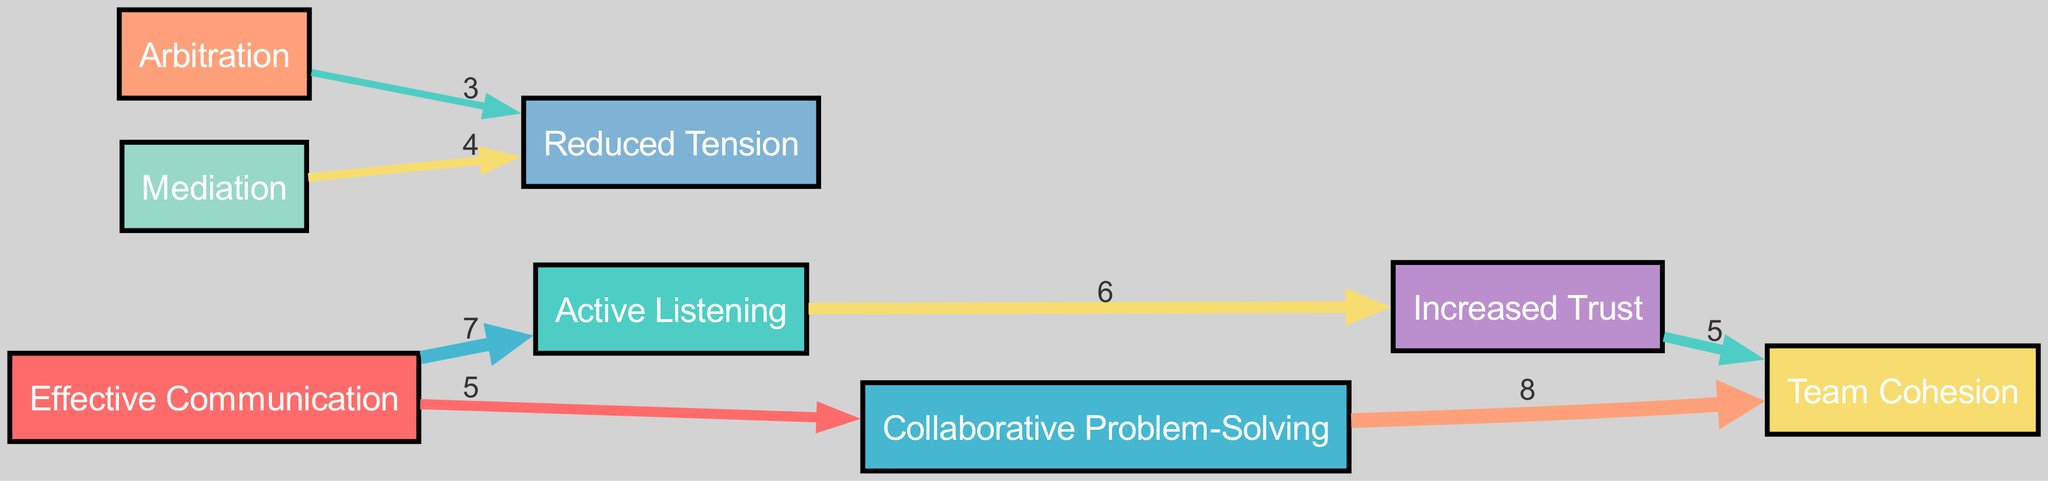What is the node that connects "Effective Communication" to "Active Listening"? "Effective Communication" has a direct link to "Active Listening" with a value of 7, indicating a strong relationship between these two concepts.
Answer: Active Listening What is the total number of nodes in the diagram? The diagram contains 8 nodes, which are: Effective Communication, Active Listening, Collaborative Problem-Solving, Arbitration, Mediation, Team Cohesion, Increased Trust, and Reduced Tension.
Answer: 8 Which approach leads to the highest value outcome for team cohesion? "Collaborative Problem-Solving" connects to "Team Cohesion" with the highest value of 8, showing it is the most effective approach for enhancing team dynamics.
Answer: Collaborative Problem-Solving What is the value of the link between "Active Listening" and "Increased Trust"? There is a link between "Active Listening" and "Increased Trust" with a value of 6, suggesting a significant impact on building trust within the team.
Answer: 6 Which conflict resolution approach has the least impact on reducing tension? "Arbitration" has a link to "Reduced Tension" with a value of 3, making it the approach with the least impact on alleviating tension compared to others.
Answer: Arbitration What is the sum of the values from "Effective Communication" to its two targets? The values from "Effective Communication" to "Active Listening" and "Collaborative Problem-Solving" are 7 and 5, respectively. Summing these gives 12, indicating the overall effectiveness of communication.
Answer: 12 Which two approaches ultimately contribute to team cohesion after going through increased trust? "Increased Trust" leads to "Team Cohesion" with a value of 5, showing that both "Active Listening" (leading to trust) and "Collaborative Problem-Solving" directly support team cohesion.
Answer: Increased Trust and Collaborative Problem-Solving What percentage of the total value does "Collaborative Problem-Solving" represent leading to "Team Cohesion"? The total value leading to "Team Cohesion" is 8, and since "Collaborative Problem-Solving" contributes fully to this value, it represents 100% of the link's impact toward team cohesion.
Answer: 100% 